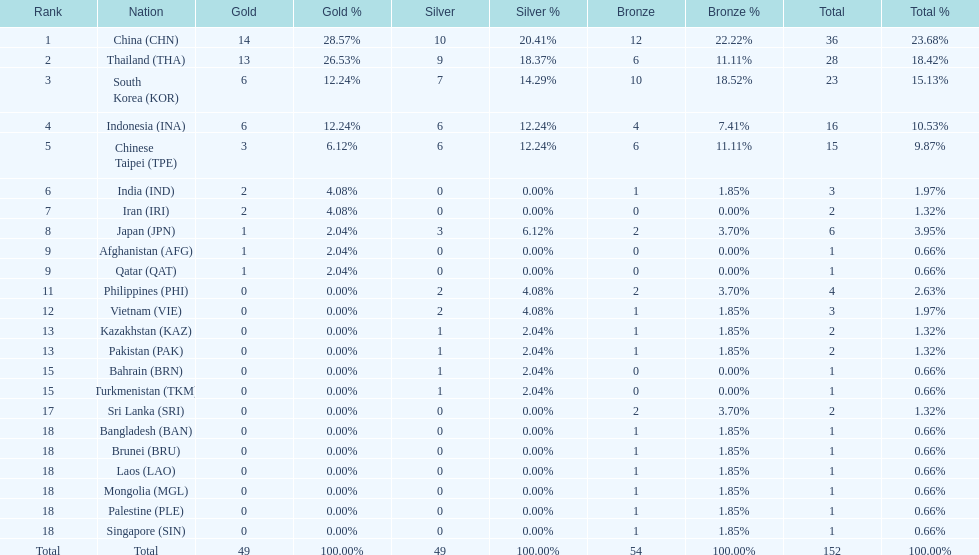How many countries received a medal in gold, silver, and bronze categories? 6. 